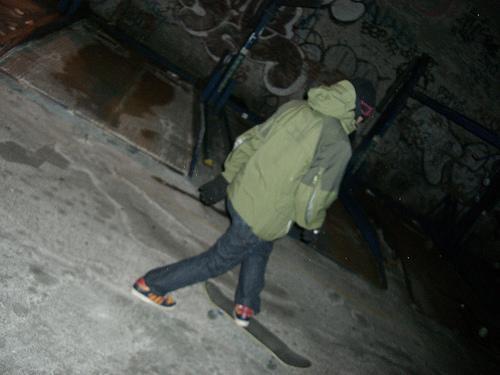How many shoes can be seen?
Give a very brief answer. 2. 